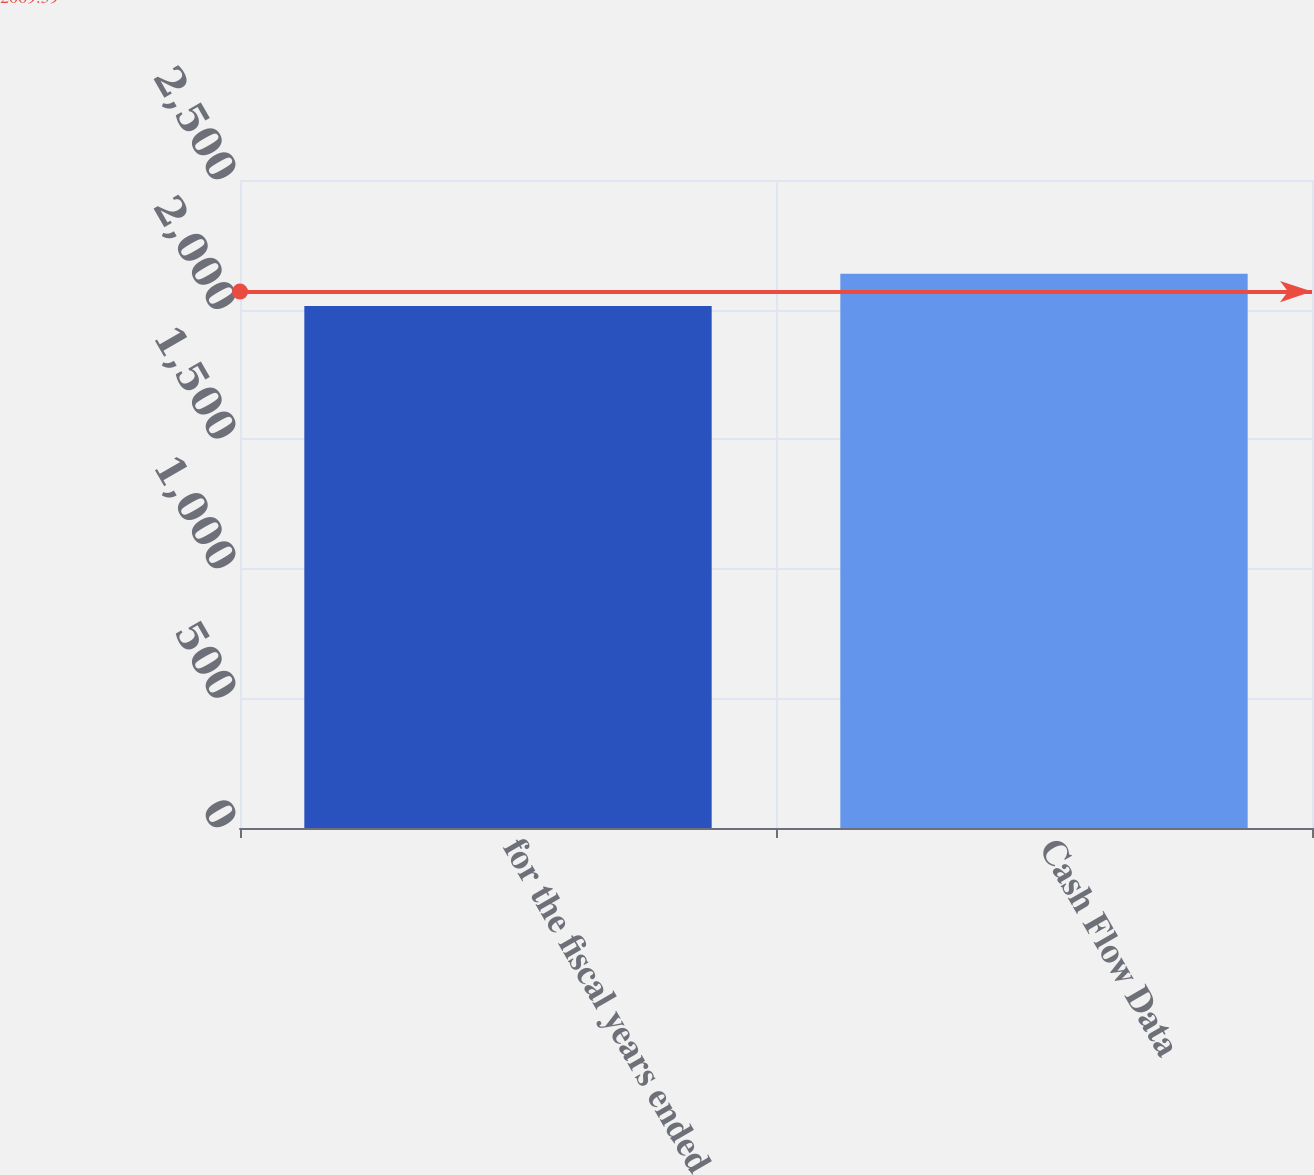Convert chart to OTSL. <chart><loc_0><loc_0><loc_500><loc_500><bar_chart><fcel>for the fiscal years ended<fcel>Cash Flow Data<nl><fcel>2014<fcel>2138<nl></chart> 